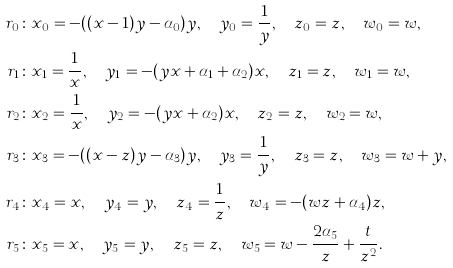<formula> <loc_0><loc_0><loc_500><loc_500>r _ { 0 } & \colon x _ { 0 } = - ( ( x - 1 ) y - \alpha _ { 0 } ) y , \quad y _ { 0 } = \frac { 1 } { y } , \quad z _ { 0 } = z , \quad w _ { 0 } = w , \\ r _ { 1 } & \colon x _ { 1 } = \frac { 1 } { x } , \quad y _ { 1 } = - ( y x + \alpha _ { 1 } + \alpha _ { 2 } ) x , \quad z _ { 1 } = z , \quad w _ { 1 } = w , \\ r _ { 2 } & \colon x _ { 2 } = \frac { 1 } { x } , \quad y _ { 2 } = - ( y x + \alpha _ { 2 } ) x , \quad z _ { 2 } = z , \quad w _ { 2 } = w , \\ r _ { 3 } & \colon x _ { 3 } = - ( ( x - z ) y - \alpha _ { 3 } ) y , \quad y _ { 3 } = \frac { 1 } { y } , \quad z _ { 3 } = z , \quad w _ { 3 } = w + y , \\ r _ { 4 } & \colon x _ { 4 } = x , \quad y _ { 4 } = y , \quad z _ { 4 } = \frac { 1 } { z } , \quad w _ { 4 } = - ( w z + \alpha _ { 4 } ) z , \\ r _ { 5 } & \colon x _ { 5 } = x , \quad y _ { 5 } = y , \quad z _ { 5 } = z , \quad w _ { 5 } = w - \frac { 2 \alpha _ { 5 } } { z } + \frac { t } { z ^ { 2 } } .</formula> 